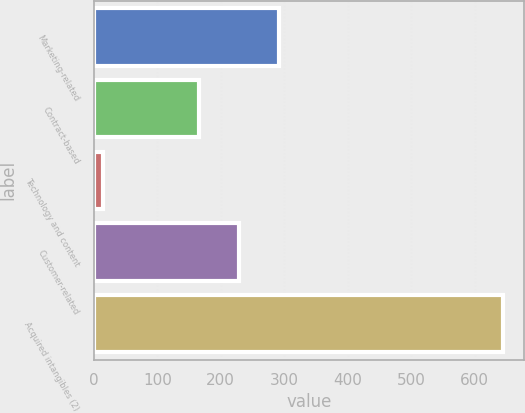Convert chart. <chart><loc_0><loc_0><loc_500><loc_500><bar_chart><fcel>Marketing-related<fcel>Contract-based<fcel>Technology and content<fcel>Customer-related<fcel>Acquired intangibles (2)<nl><fcel>292<fcel>166<fcel>15<fcel>229<fcel>645<nl></chart> 